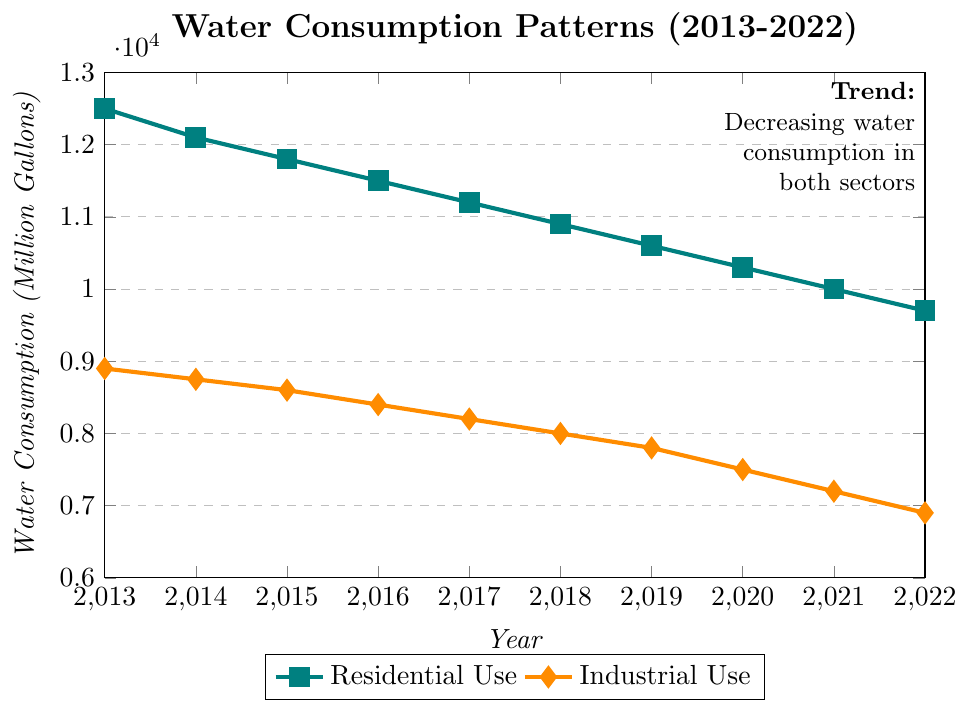What is the overall trend in residential water use from 2013 to 2022? The line for residential water use shows a consistent downward trend from 12,500 million gallons in 2013 to 9,700 million gallons in 2022.
Answer: Downward trend Which year had the highest industrial water consumption, and what was the value? The year 2013 had the highest industrial water consumption, depicted by the highest point on the industrial use line. The value is 8,900 million gallons.
Answer: 2013, 8,900 million gallons By how much did the residential water use decrease between 2013 and 2022? Residential water use in 2013 was 12,500 million gallons, and in 2022 it was 9,700 million gallons. The decrease is 12,500 - 9,700 = 2,800 million gallons.
Answer: 2,800 million gallons In which years did both residential and industrial water use decrease compared to the previous years? Manual inspection of the lines indicates that both residential and industrial water use decreased every year from 2013 to 2022.
Answer: Every year from 2014 to 2022 What was the total water consumption (residential plus industrial) in the year 2018? Add the residential use (10,900 million gallons) and industrial use (8,000 million gallons) for 2018: 10,900 + 8,000 = 18,900 million gallons.
Answer: 18,900 million gallons Which sector had a sharper decline in water consumption over the decade? Calculate the decline for each sector: Residential went from 12,500 to 9,700 (decrease of 2,800 million gallons), Industrial went from 8,900 to 6,900 (decrease of 2,000 million gallons). Despite a larger initial value, residential had a sharper decline in absolute terms.
Answer: Residential sector What was the average industrial water use over the decade? Sum the industrial uses and divide by the number of years: (8,900 + 8,750 + 8,600 + 8,400 + 8,200 + 8,000 + 7,800 + 7,500 + 7,200 + 6,900) / 10 = 8,225 million gallons.
Answer: 8,225 million gallons By comparing the slopes of the lines for residential and industrial use from 2021 to 2022, which sector saw a greater change in water usage? The decrease in residential use from 2021 to 2022 is 10,000 - 9,700 = 300 million gallons. For industrial, it's 7,200 - 6,900 = 300 million gallons. Both sectors saw the same change in water usage.
Answer: Both sectors saw the same change What is the difference in industrial water use between the years 2016 and 2020? Industrial water use in 2016 was 8,400 million gallons, and in 2020 it was 7,500 million gallons. The difference is 8,400 - 7,500 = 900 million gallons.
Answer: 900 million gallons What is the percentage decrease in residential water use from 2018 to 2022? The residential use in 2018 was 10,900 million gallons, and in 2022 it was 9,700 million gallons. The decrease is 10,900 - 9,700 = 1,200 million gallons. The percentage decrease is (1,200 / 10,900) * 100 ≈ 11.0%.
Answer: 11.0% 